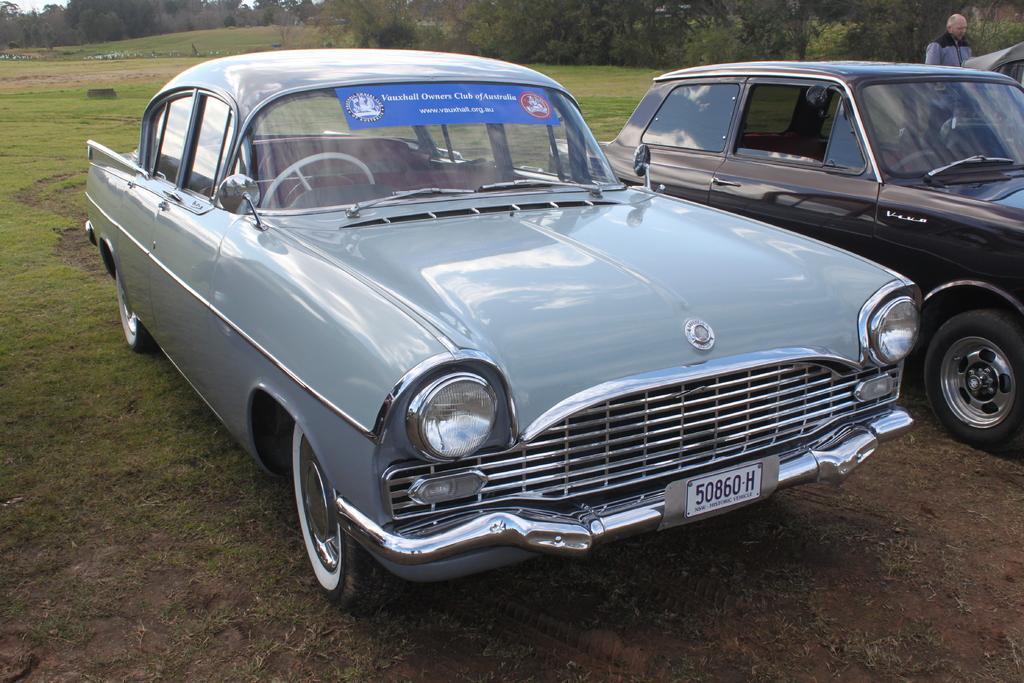In one or two sentences, can you explain what this image depicts? In this image I see 2 cars over here and I see blue color paper on which there are words written and I see 2 logos and I see the number plate over here and I see the ground on which there is grass and I see a man over here. In the background I see number of trees. 